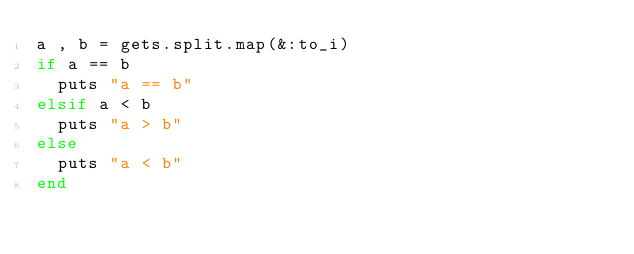<code> <loc_0><loc_0><loc_500><loc_500><_Ruby_>a , b = gets.split.map(&:to_i)
if a == b
  puts "a == b"
elsif a < b
  puts "a > b"
else
  puts "a < b"
end</code> 